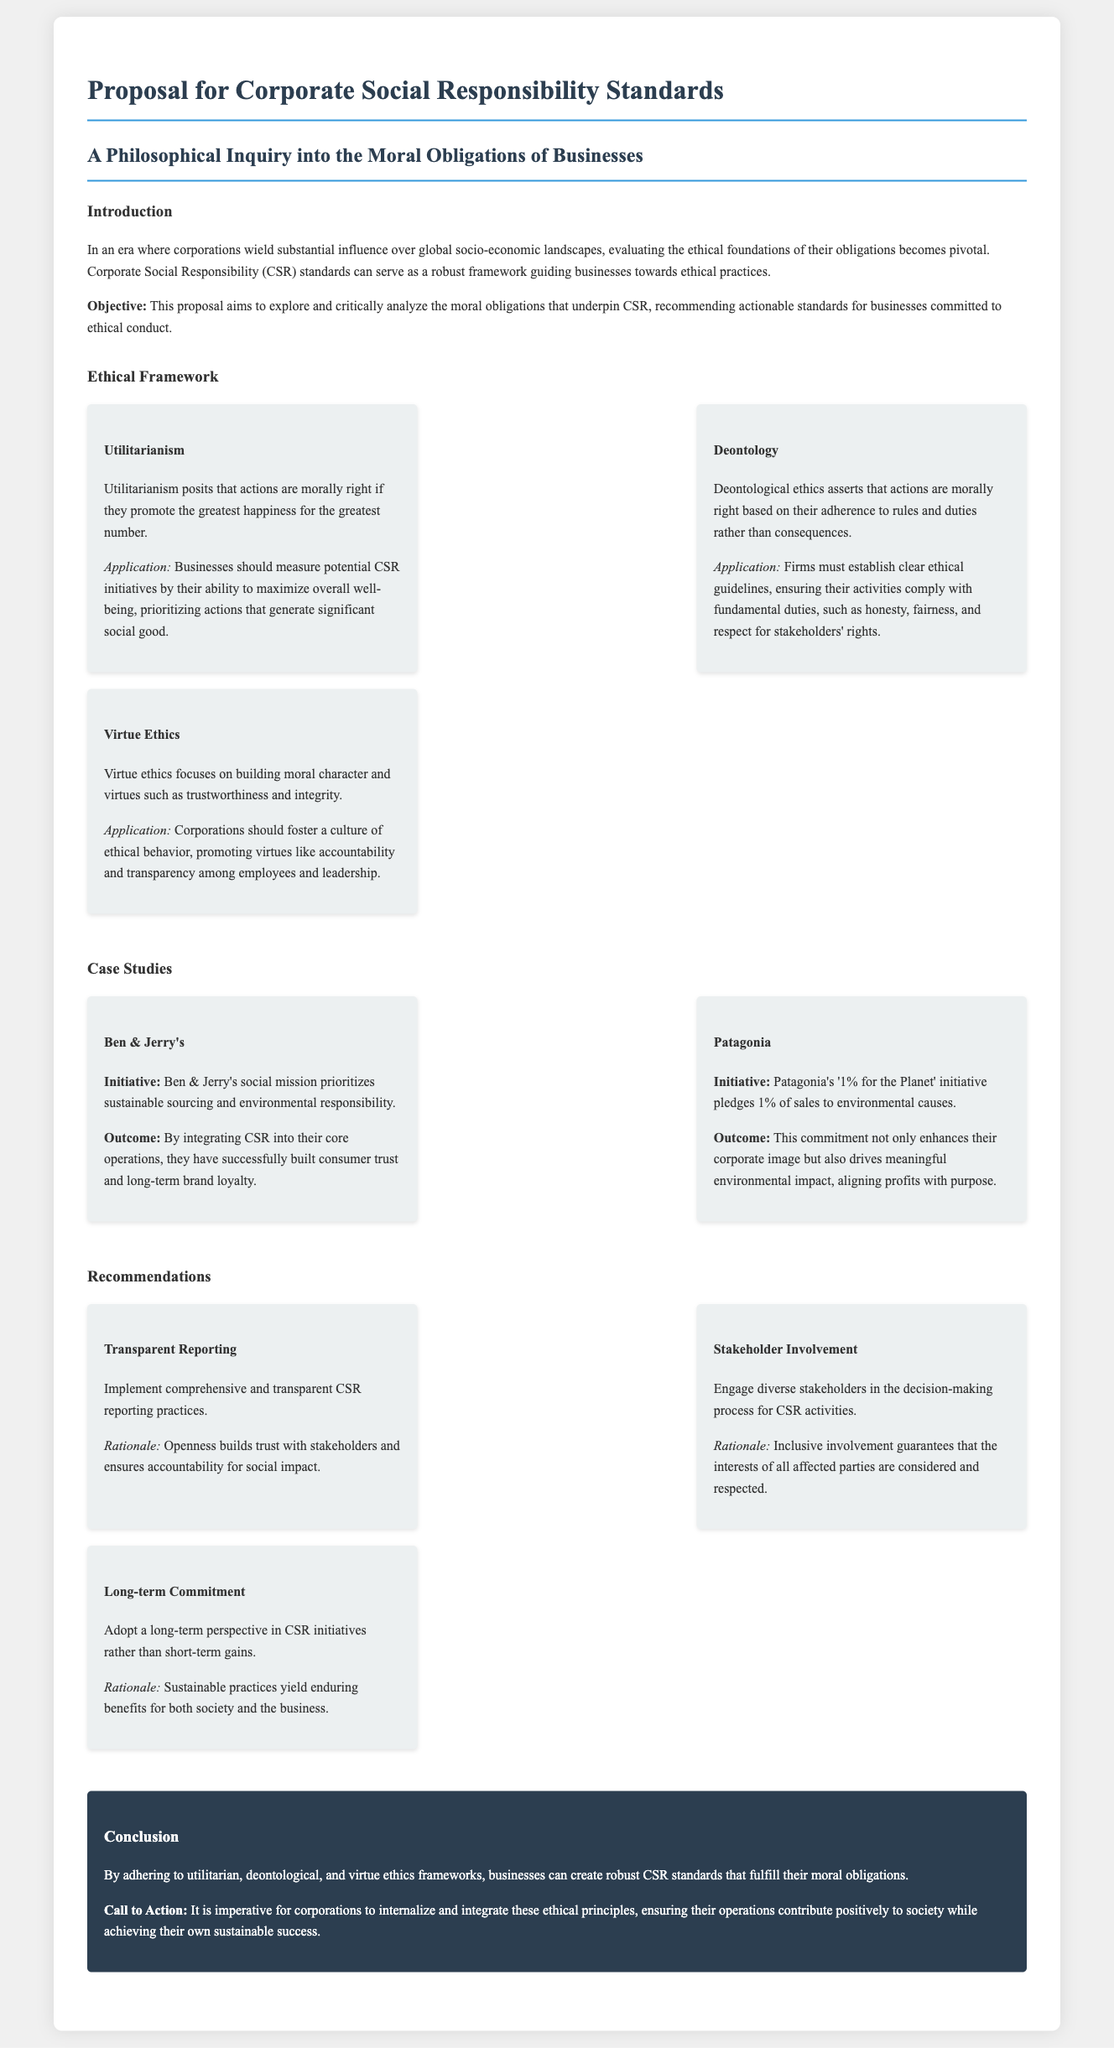What is the title of the proposal? The title of the proposal is specified in the document header.
Answer: Proposal for Corporate Social Responsibility Standards What ethical framework does utilitarianism belong to? Utilitarianism is mentioned as one of the ethical frameworks within the proposal.
Answer: Ethical Framework How many case studies are presented in the proposal? The proposal lists two specific case studies illustrating corporate responsibility initiatives.
Answer: Two What is one initiative of Patagonia mentioned in the case studies? An initiative of Patagonia is highlighted in the respective case study section of the proposal.
Answer: '1% for the Planet' What is the first recommendation listed for CSR practices? The proposal presents several recommendations and the first one is outlined in the recommendations section.
Answer: Transparent Reporting What is the focus of virtue ethics according to the document? The document describes virtue ethics in relation to corporate behavior and moral character.
Answer: Building moral character What is the call to action mentioned in the conclusion? A specific call to action is provided in the conclusion of the proposal to guide corporations.
Answer: Internalize and integrate these ethical principles What does the acronym CSR stand for? The document uses this acronym multiple times, defining its relevance throughout the text.
Answer: Corporate Social Responsibility What is one outcome of Ben & Jerry's initiative as stated in the document? The proposal mentions outcomes of the case studies in relation to the companies' CSR practices.
Answer: Consumer trust and long-term brand loyalty 